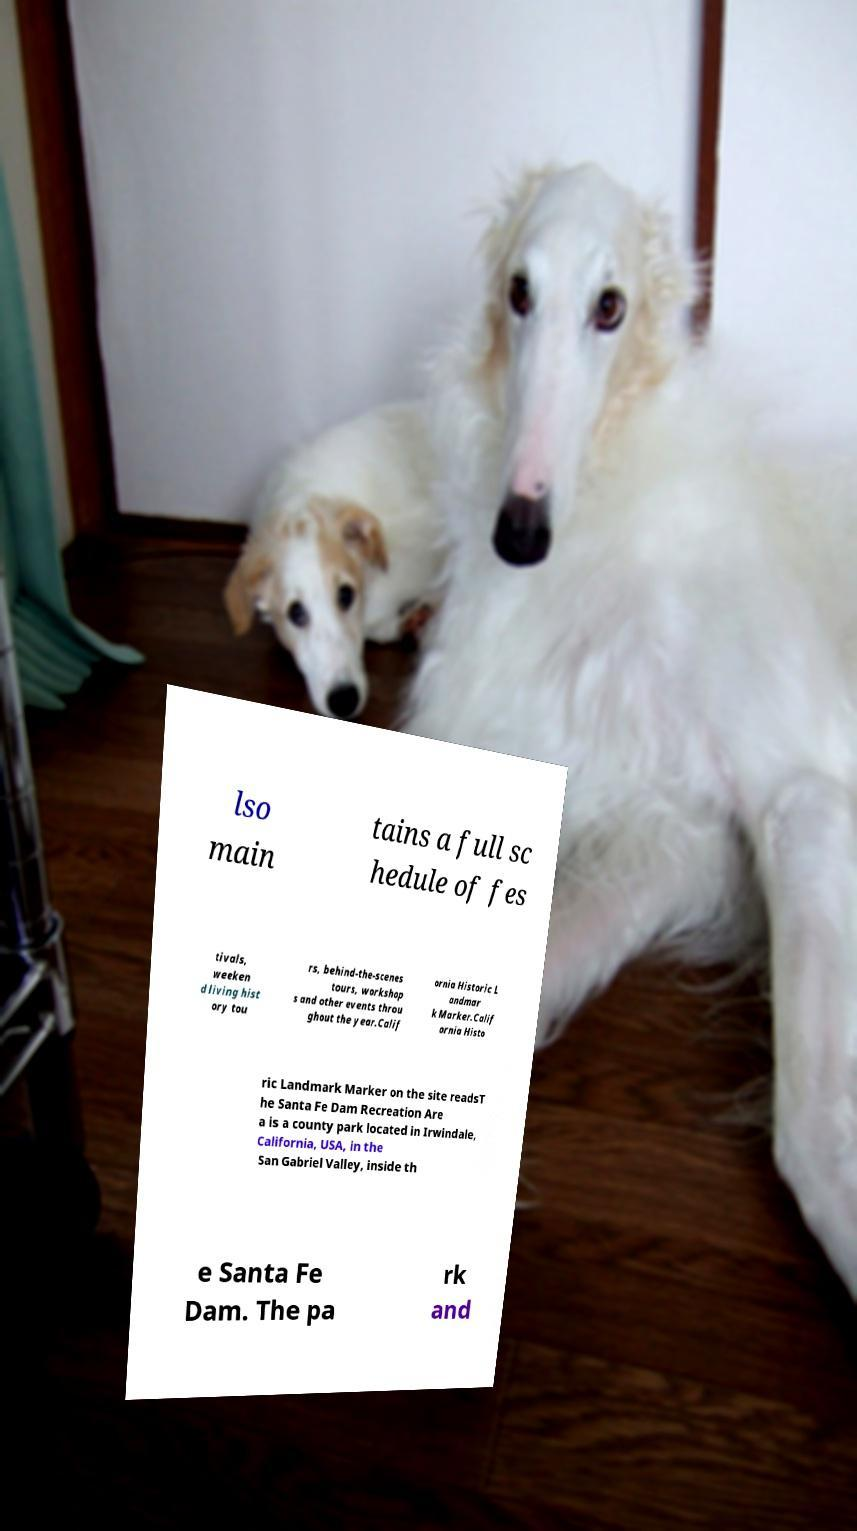For documentation purposes, I need the text within this image transcribed. Could you provide that? lso main tains a full sc hedule of fes tivals, weeken d living hist ory tou rs, behind-the-scenes tours, workshop s and other events throu ghout the year.Calif ornia Historic L andmar k Marker.Calif ornia Histo ric Landmark Marker on the site readsT he Santa Fe Dam Recreation Are a is a county park located in Irwindale, California, USA, in the San Gabriel Valley, inside th e Santa Fe Dam. The pa rk and 